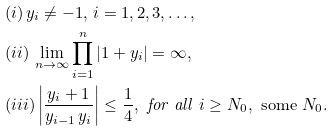<formula> <loc_0><loc_0><loc_500><loc_500>& ( i ) \, y _ { i } \not = - 1 , \, i = 1 , 2 , 3 , \dots , \\ & ( i i ) \, \lim _ { n \to \infty } \prod _ { i = 1 } ^ { n } | 1 + y _ { i } | = \infty , \\ & ( i i i ) \left | \frac { y _ { i } + 1 } { y _ { i - 1 } \, y _ { i } } \right | \leq \frac { 1 } { 4 } , \text { \emph{for all }} i \geq N _ { 0 } , \text { some } N _ { 0 } .</formula> 